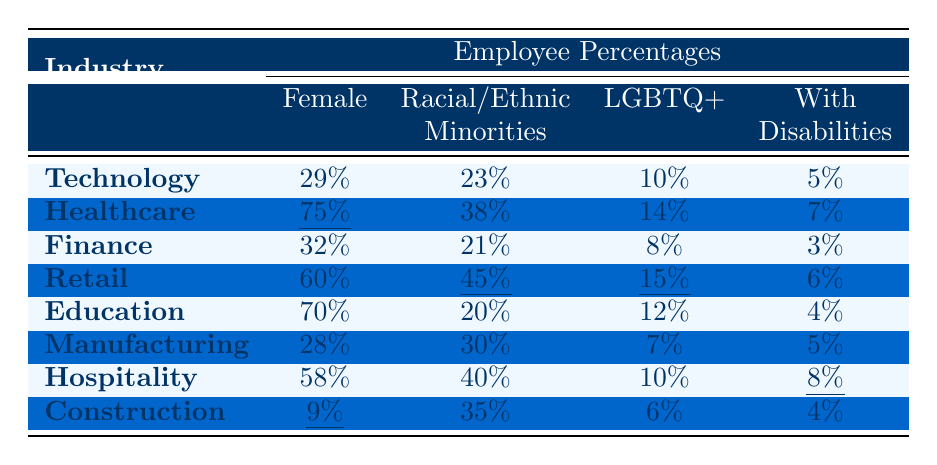What is the female employee percentage in the Healthcare industry? The table shows the Female Employee Percentage for Healthcare as 75%.
Answer: 75% Which industry has the highest percentage of racial/ethnic minorities? By comparing the Racial/Ethnic Minorities Percentages, Retail has the highest at 45%.
Answer: Retail Is the LGBTQ+ employee percentage higher in Technology than in Finance? Technology has an LGBTQ+ employee percentage of 10%, while Finance has 8%. Therefore, yes, Technology is higher.
Answer: Yes What is the average percentage of employees with disabilities across all industries? The percentages of employees with disabilities are 5, 7, 3, 6, 4, 5, 8, and 4. Summing these gives 38, and dividing by 8 gives an average of 4.75%.
Answer: 4.75% In which industry is the percentage of female employees lower than that of employees with disabilities? In Construction, the Female Employee Percentage is 9%, which is lower than the 4% for employees with disabilities.
Answer: Construction Which industry has the lowest percentage of female employees, and what is that percentage? The table indicates that Construction has the lowest female employee percentage at 9%.
Answer: 9% Is it true that the percentage of racial/ethnic minorities in Hospitality is greater than in Education? The percentages show 40% in Hospitality and 20% in Education, so this statement is true.
Answer: True If we combine the percentages of female employees and LGBTQ+ employees in the Retail industry, what is the total? The percentages for Retail are 60% for females and 15% for LGBTQ+, summing these gives 75%.
Answer: 75% Which industries have the same percentage of employees with disabilities? The percentages for Manufacturing and Construction are both at 5%. Hence, they are the same.
Answer: Manufacturing and Construction If you sum the percentages of female employees in the Technology and Finance industries, what do you get? The percentages are 29% for Technology and 32% for Finance. Adding these gives 61%.
Answer: 61% 